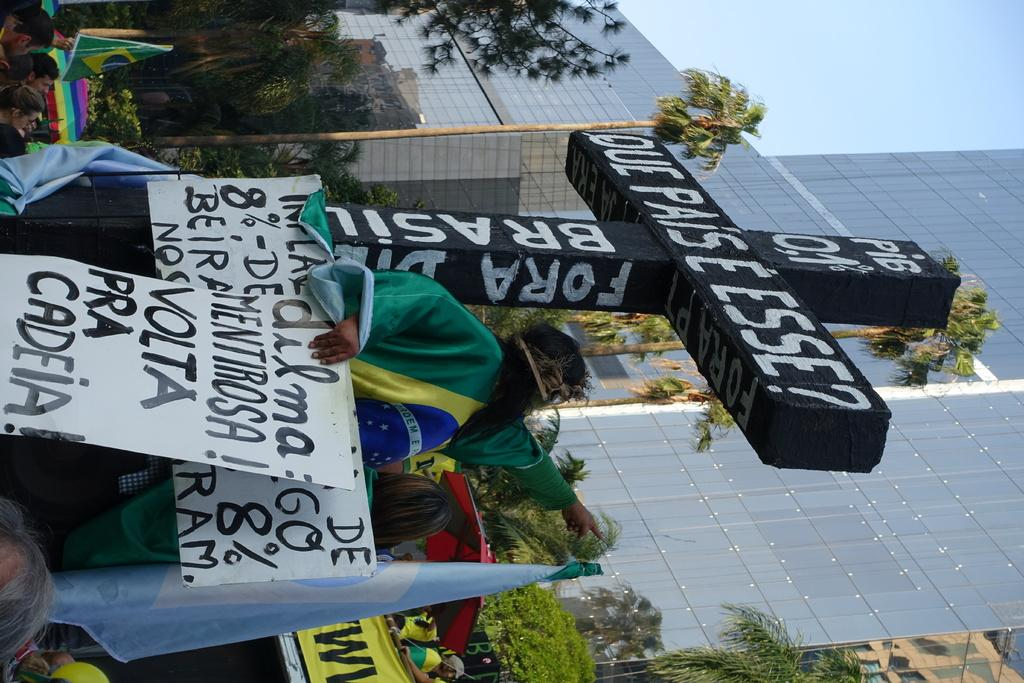What are the people in the image holding? The people in the image are holding flags. What other objects with text can be seen in the image? There are boards with text and a cross with text in the image. What additional decorative elements are present in the image? There are banners in the image. What can be seen in the background of the image? There are trees, a building, and the sky visible in the background of the image. What color is the sister's dress in the image? There is no mention of a sister or a dress in the image. 